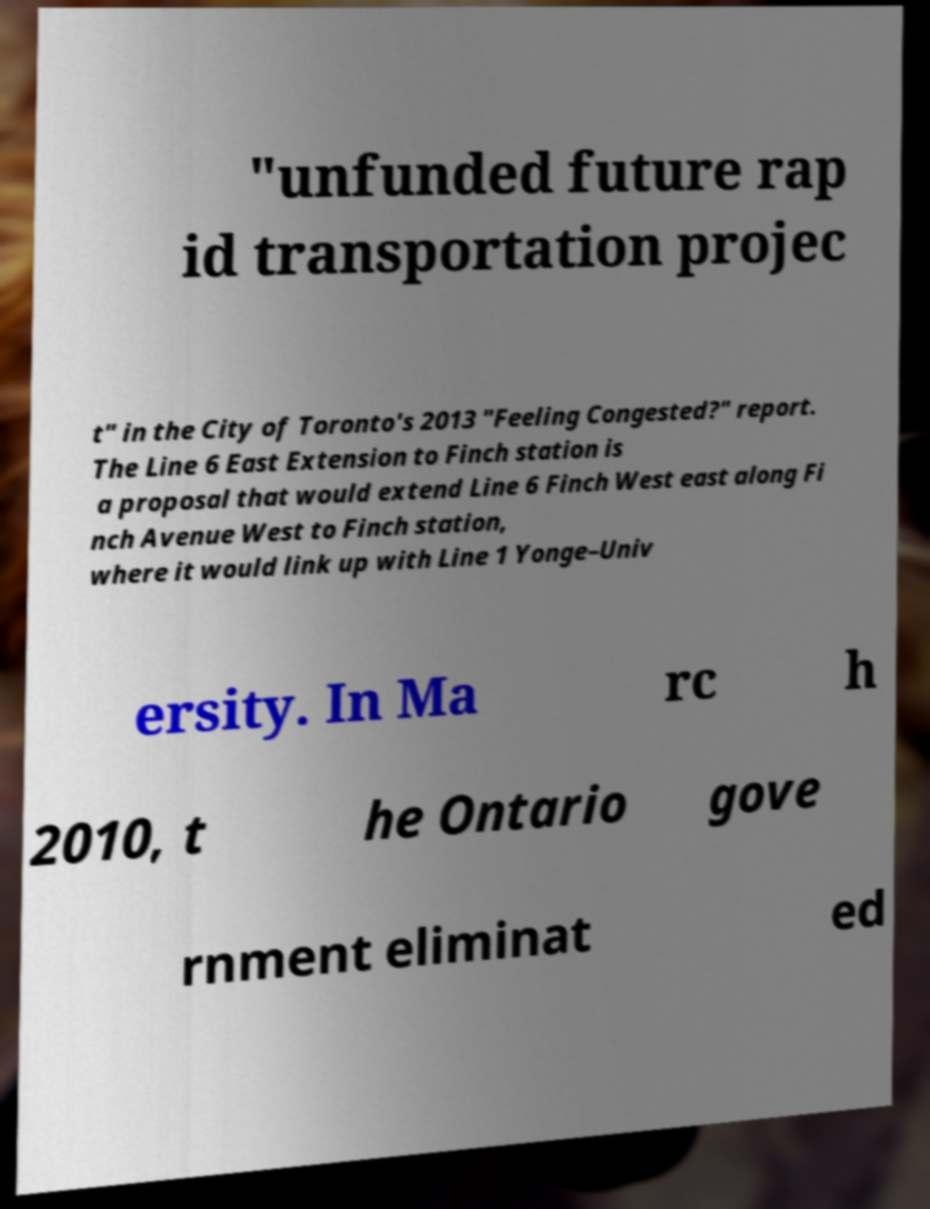Can you accurately transcribe the text from the provided image for me? "unfunded future rap id transportation projec t" in the City of Toronto's 2013 "Feeling Congested?" report. The Line 6 East Extension to Finch station is a proposal that would extend Line 6 Finch West east along Fi nch Avenue West to Finch station, where it would link up with Line 1 Yonge–Univ ersity. In Ma rc h 2010, t he Ontario gove rnment eliminat ed 